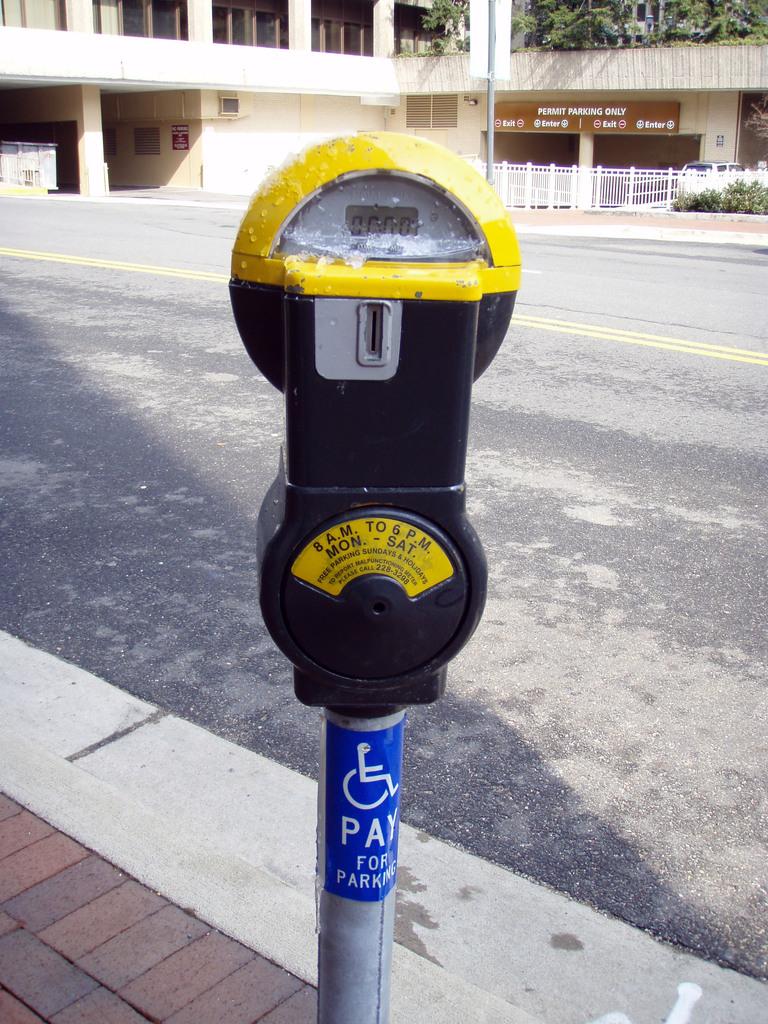How much time is left on the meter?
Your answer should be compact. 0. What does the blue label say?
Keep it short and to the point. Pay for parking. 